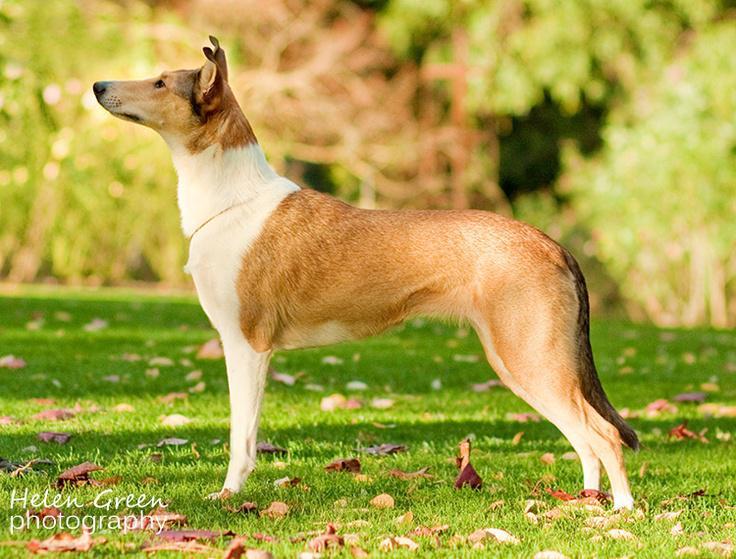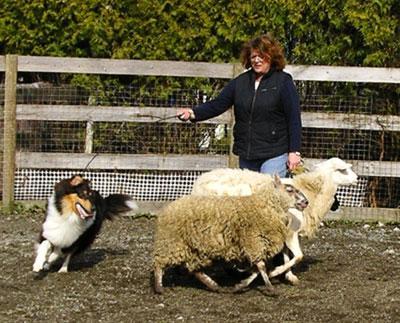The first image is the image on the left, the second image is the image on the right. Evaluate the accuracy of this statement regarding the images: "An image shows a dog behind three sheep which are moving leftward.". Is it true? Answer yes or no. No. 